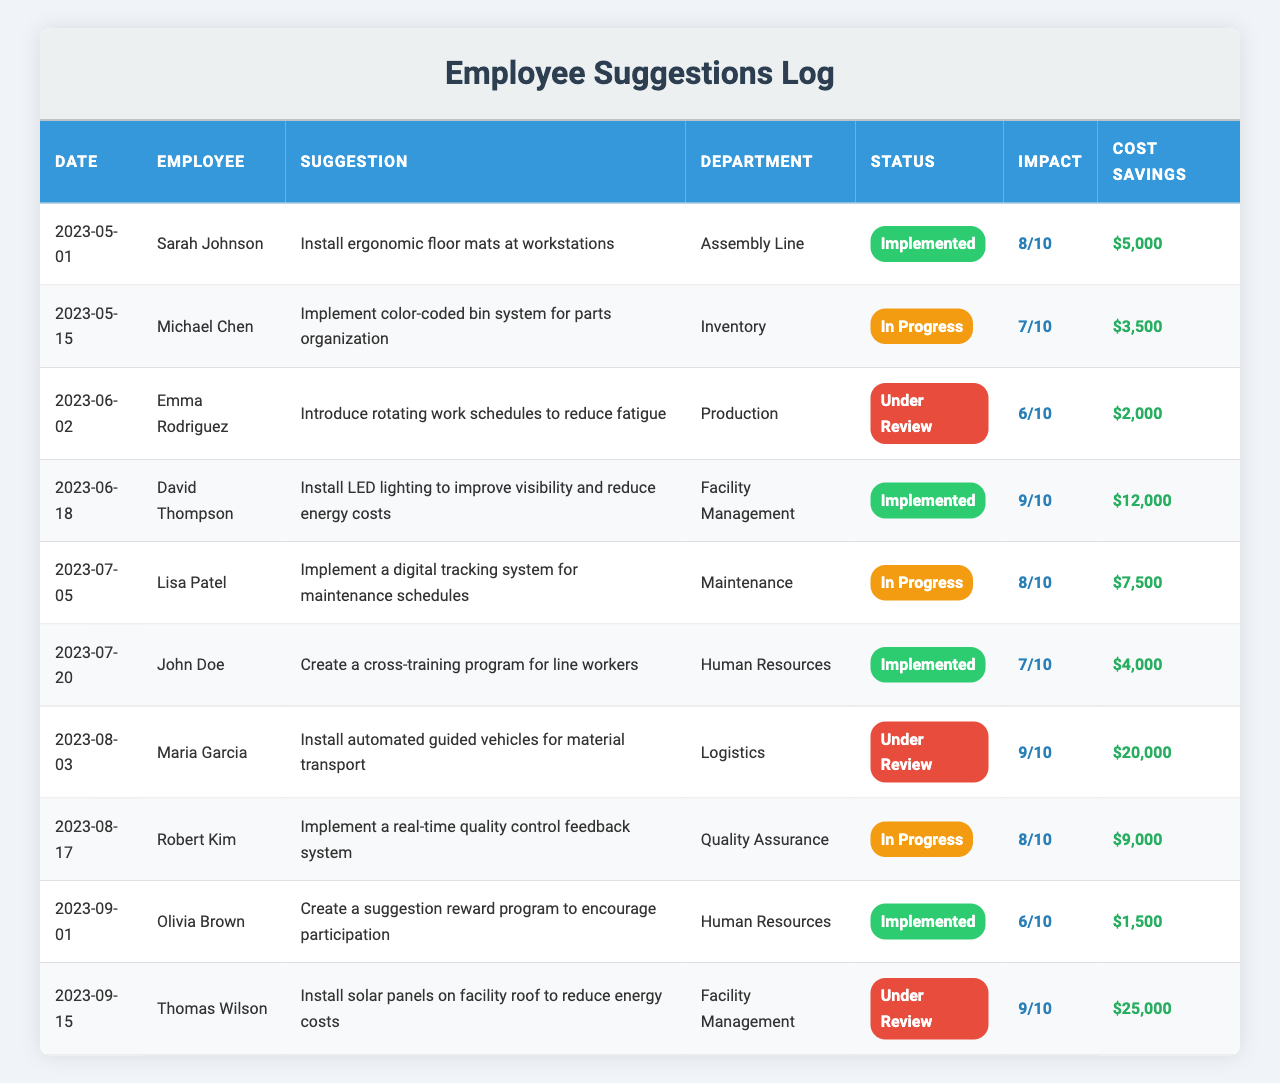What is the suggestion made by David Thompson? The table shows several suggestions along with the employee names. By searching for the row containing David Thompson, we find that his suggestion is to "Install LED lighting to improve visibility and reduce energy costs".
Answer: Install LED lighting to improve visibility and reduce energy costs How many suggestions are currently under review? Looking at the Implementation_Status column, we can count the entries marked as "Under Review." There are three such entries (from Emma Rodriguez, Maria Garcia, and Thomas Wilson).
Answer: 3 Which employee's suggestion has the highest impact rating? By scanning through the Impact_Rating column, we can determine that the highest rating is 9. Checking against the corresponding entries reveals that David Thompson and Maria Garcia both have suggestions rated 9.
Answer: David Thompson and Maria Garcia What is the total cost savings from all implemented suggestions? We identify the suggestions with the status "Implemented" and then sum their Cost Savings values: $5000 (Sarah Johnson) + $12000 (David Thompson) + $4000 (John Doe) + $1500 (Olivia Brown) = $20500.
Answer: $20,500 Is there any suggestion related to energy costs? Checking the table, we find suggestions relating to energy costs from David Thompson (LED lighting) and Thomas Wilson (solar panels). Both suggestions mention reducing energy costs.
Answer: Yes What is the average impact rating of suggestions that are currently in progress? We note the suggestions in the "In Progress" status and their impact ratings: 7 (Michael Chen), 8 (Lisa Patel), and 8 (Robert Kim). The average is calculated as (7 + 8 + 8) / 3 = 7.67.
Answer: 7.67 Which department has the most suggestions? Looking through the Department column, we can count the occurrences: Assembly Line (1), Inventory (1), Production (1), Facility Management (2), Maintenance (1), Human Resources (2), Logistics (1), and Quality Assurance (1). Human Resources and Facility Management both have the most suggestions (2 each).
Answer: Human Resources and Facility Management How many suggestions have an impact rating of 8 or higher? By inspecting the Impact_Rating column, we find the ratings: 8 (Sarah Johnson), 9 (David Thompson), 8 (Lisa Patel), 9 (Maria Garcia), and 8 (Robert Kim). This adds up to five suggestions with ratings of 8 or higher.
Answer: 5 What percentage of suggestions have been implemented? There are 10 total suggestions, with 4 being implemented. To find the percentage, we calculate (4 / 10) * 100 = 40%.
Answer: 40% Which suggestion has the highest potential cost savings? Reviewing the Cost Savings entries, we see that the suggestion made by Maria Garcia has the highest potential cost savings at $20,000.
Answer: Install automated guided vehicles for material transport 